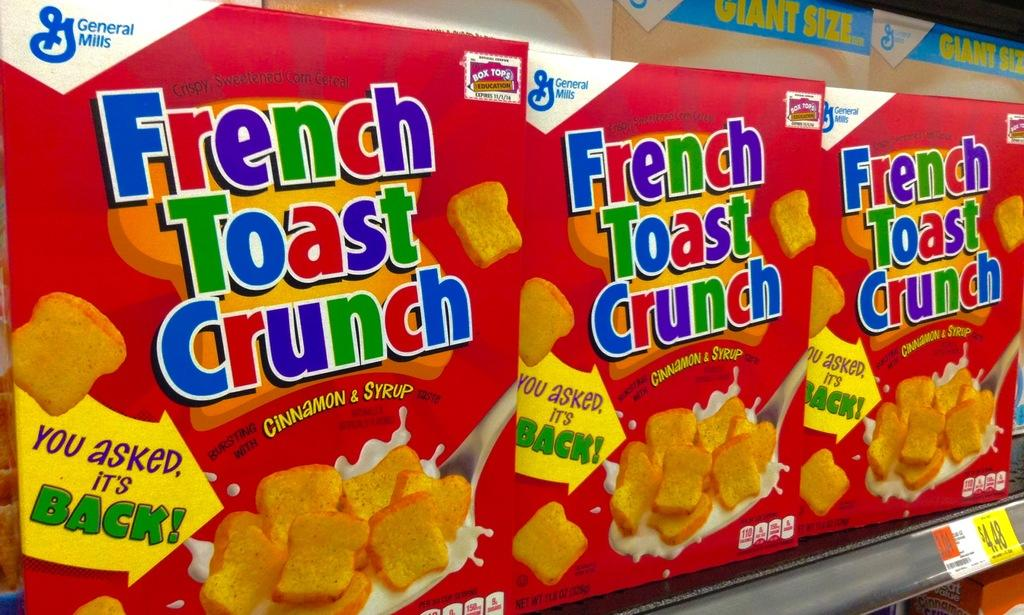What type of food items are in the image? There are toast boxes in the image. How are the toast boxes arranged in the image? The toast boxes are kept in a rack. Is there any information about the cost of the toast boxes in the image? Yes, there is a price tag in the image. On which side of the image is the price tag located? The price tag is on the right side. What is the wind speed in the image? There is no information about wind speed in the image, as it does not feature any outdoor or weather-related elements. 